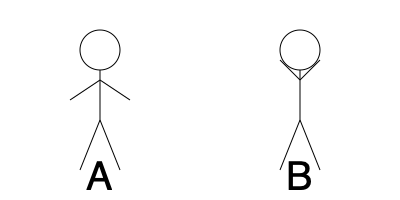In a romantic comedy scene, which stick figure representation (A or B) displays more positive body language, likely indicating a character's openness and interest in their love interest? To determine which stick figure displays more positive body language, we need to analyze the body posture of each figure:

1. Figure A:
   - Arms are relaxed and slightly open
   - Stance is neutral and balanced
   - Head is upright and centered

2. Figure B:
   - Arms are raised and angled upwards
   - Stance is similar to Figure A
   - Head is upright and centered

Analyzing these cues:

1. Open arms (Figure A) typically indicate openness, receptiveness, and a welcoming attitude. This is a positive body language cue often used in romantic scenes to show interest and approachability.

2. Raised arms (Figure B) can sometimes indicate excitement or celebration, but in the context of a romantic interaction, they might appear defensive or closed off.

3. Both figures have similar stances and head positions, which are neutral and don't significantly impact the overall body language interpretation.

In the context of a romantic comedy scene, Figure A's open arm position is more likely to convey positive body language, indicating the character's openness and interest in their love interest. This posture aligns with the uplifting and positive messages that romance film activists often promote, as it suggests a character who is receptive to forming connections and expressing vulnerability.
Answer: A 